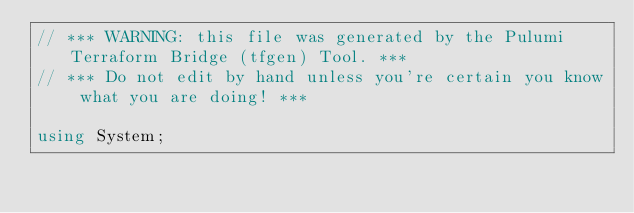<code> <loc_0><loc_0><loc_500><loc_500><_C#_>// *** WARNING: this file was generated by the Pulumi Terraform Bridge (tfgen) Tool. ***
// *** Do not edit by hand unless you're certain you know what you are doing! ***

using System;</code> 